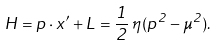<formula> <loc_0><loc_0><loc_500><loc_500>H = { p } \cdot { x ^ { \prime } } + L = { \frac { 1 } { 2 } } \, \eta \, ( p ^ { 2 } - \mu ^ { 2 } ) .</formula> 